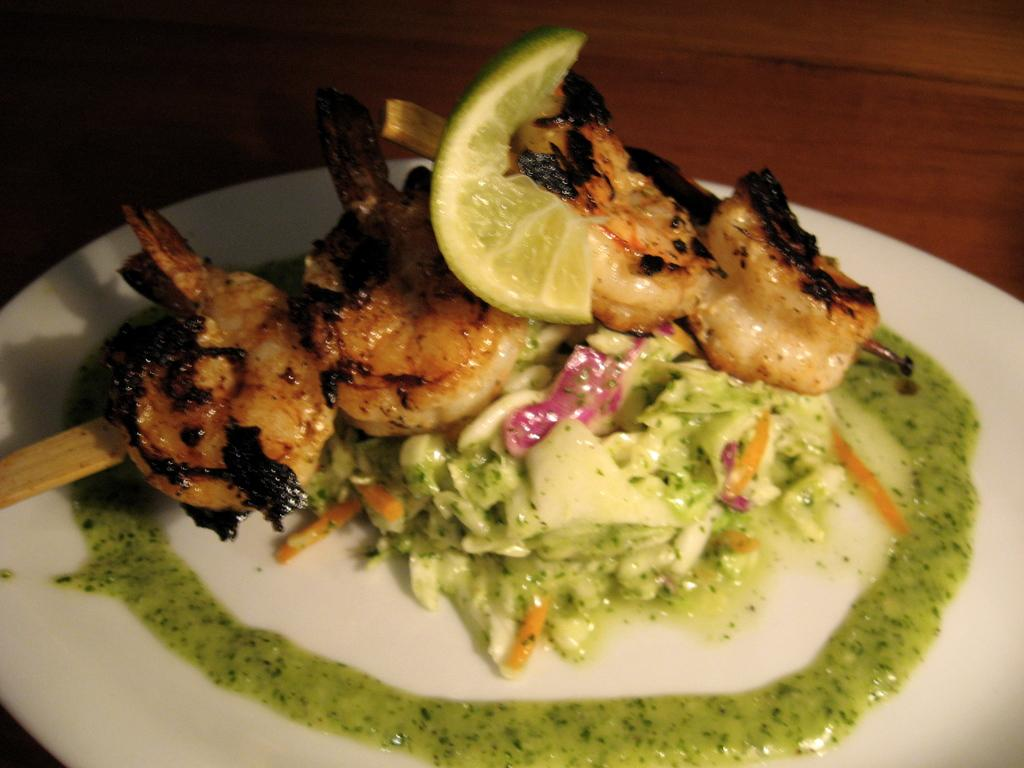What type of food can be seen in the image? There is food in the image, but the specific type is not mentioned. What is one ingredient or topping visible on the food? The food contains a lemon slice. What type of sauce is on the food? The food contains sos. Where is the plate with the food located? The plate is placed on a table. What is the position of the parent in the image? There is no parent present in the image, as the facts only mention food, a lemon slice, sos, a plate, and a table. 